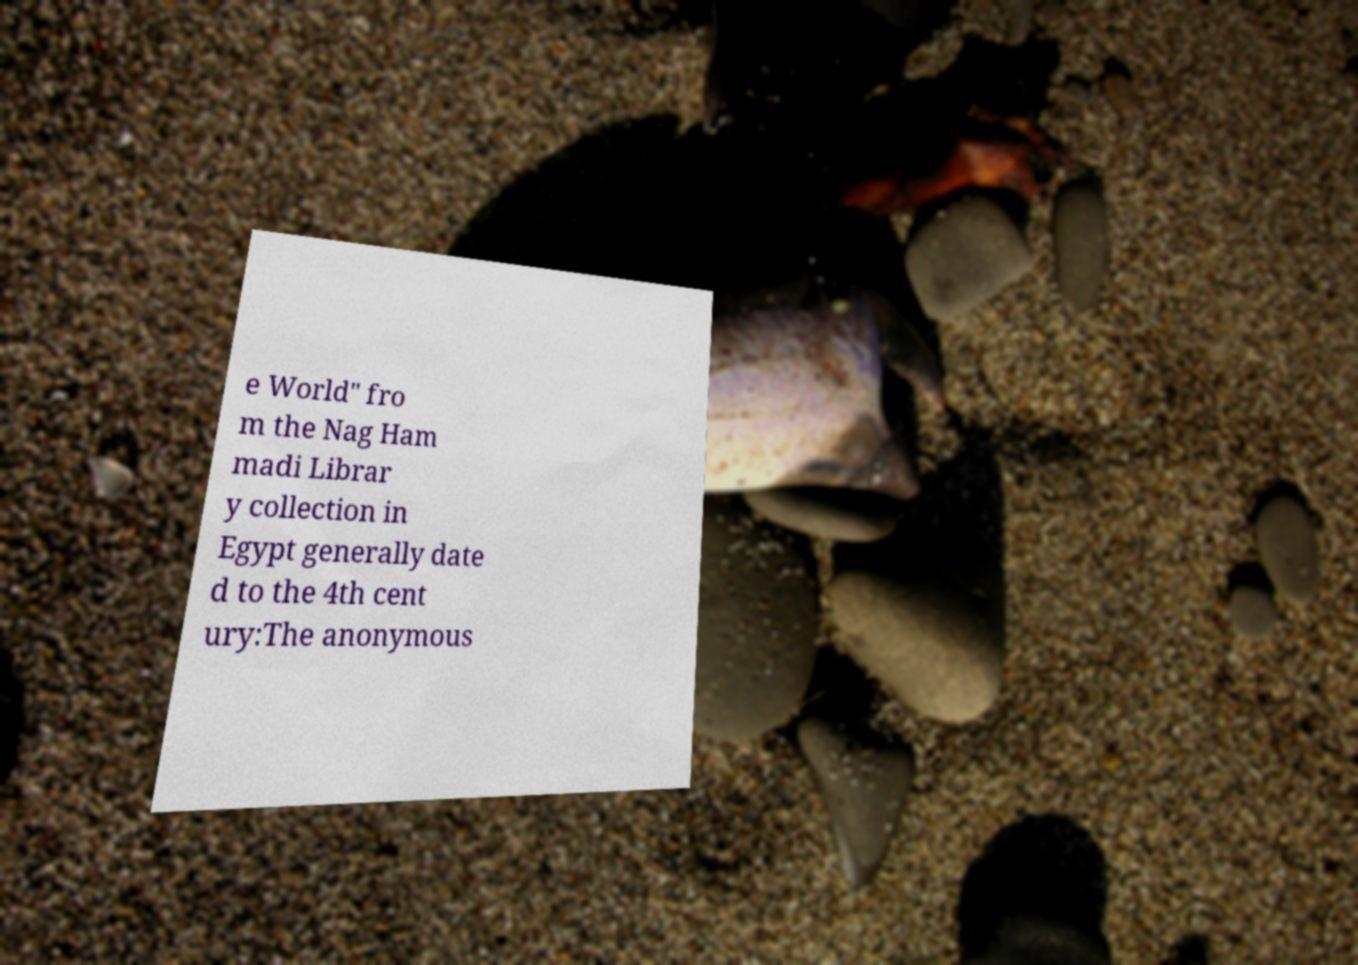There's text embedded in this image that I need extracted. Can you transcribe it verbatim? e World" fro m the Nag Ham madi Librar y collection in Egypt generally date d to the 4th cent ury:The anonymous 